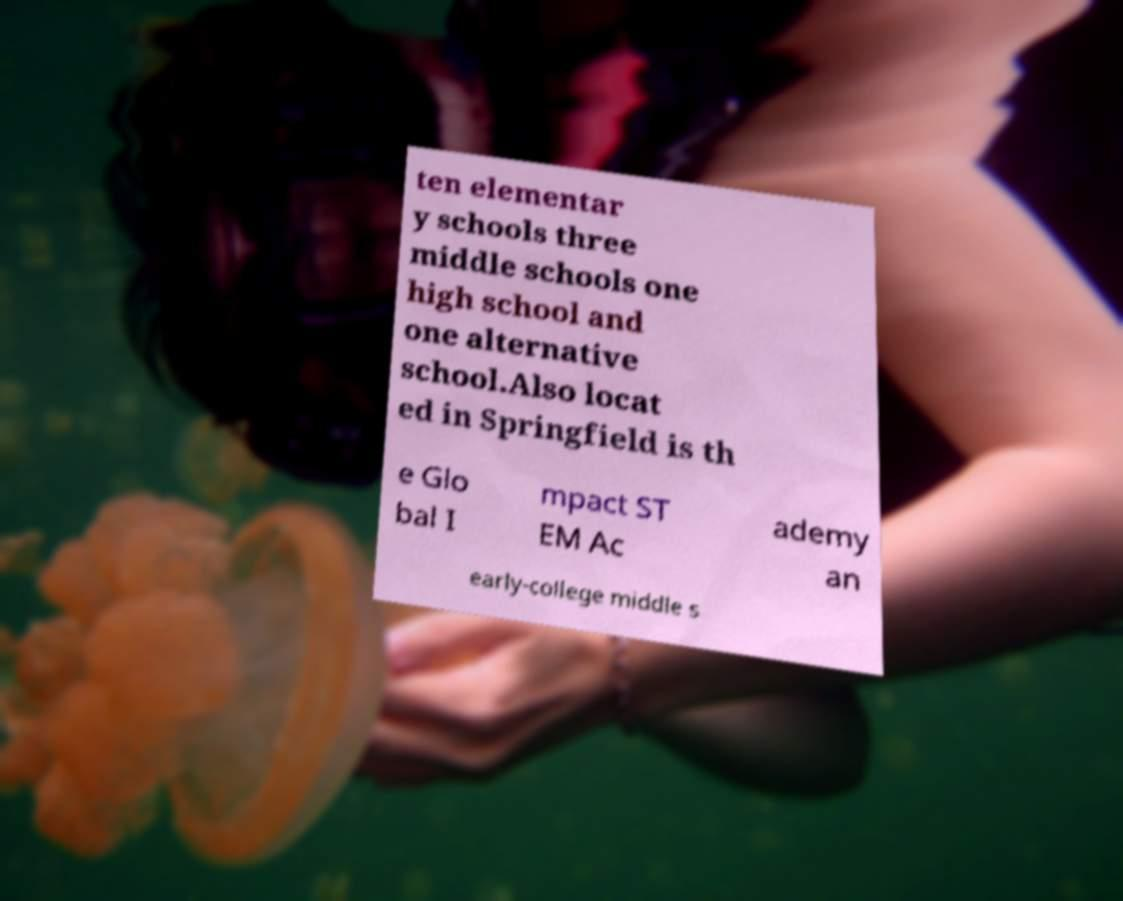Could you assist in decoding the text presented in this image and type it out clearly? ten elementar y schools three middle schools one high school and one alternative school.Also locat ed in Springfield is th e Glo bal I mpact ST EM Ac ademy an early-college middle s 